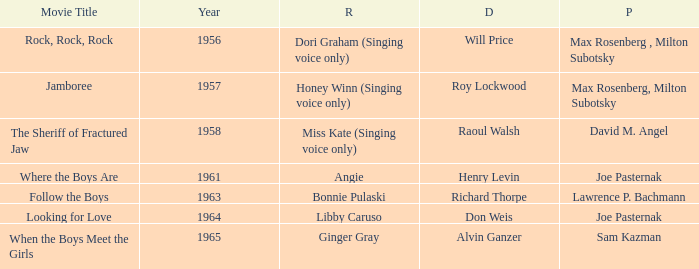What movie was made in 1957? Jamboree. 